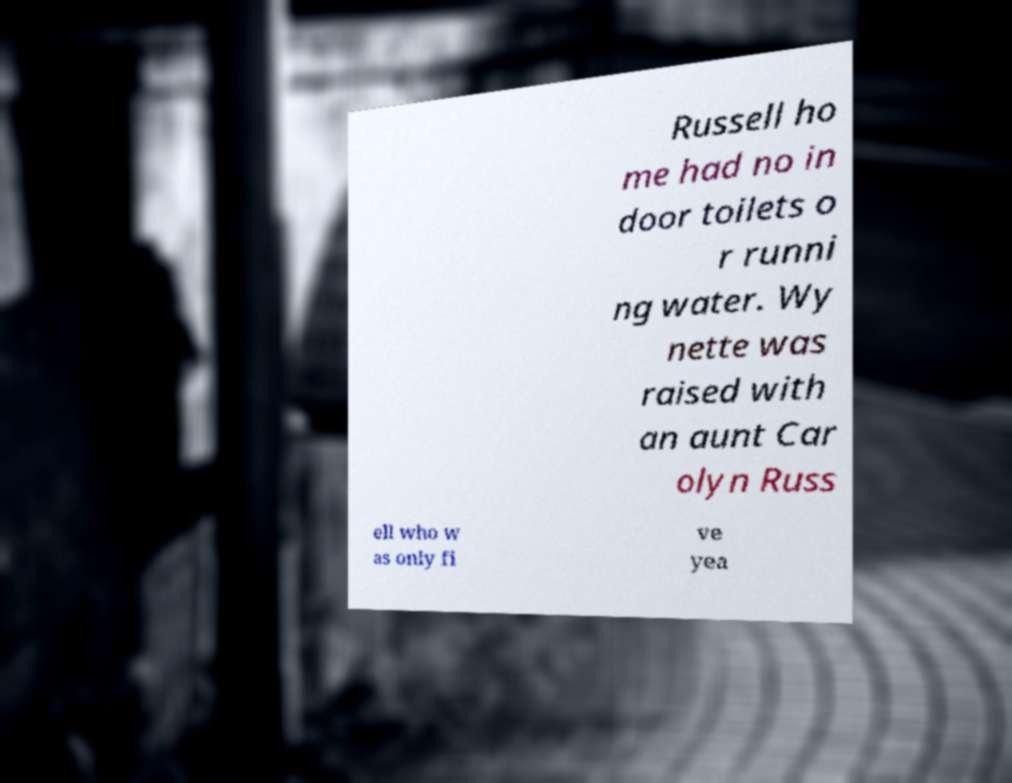For documentation purposes, I need the text within this image transcribed. Could you provide that? Russell ho me had no in door toilets o r runni ng water. Wy nette was raised with an aunt Car olyn Russ ell who w as only fi ve yea 